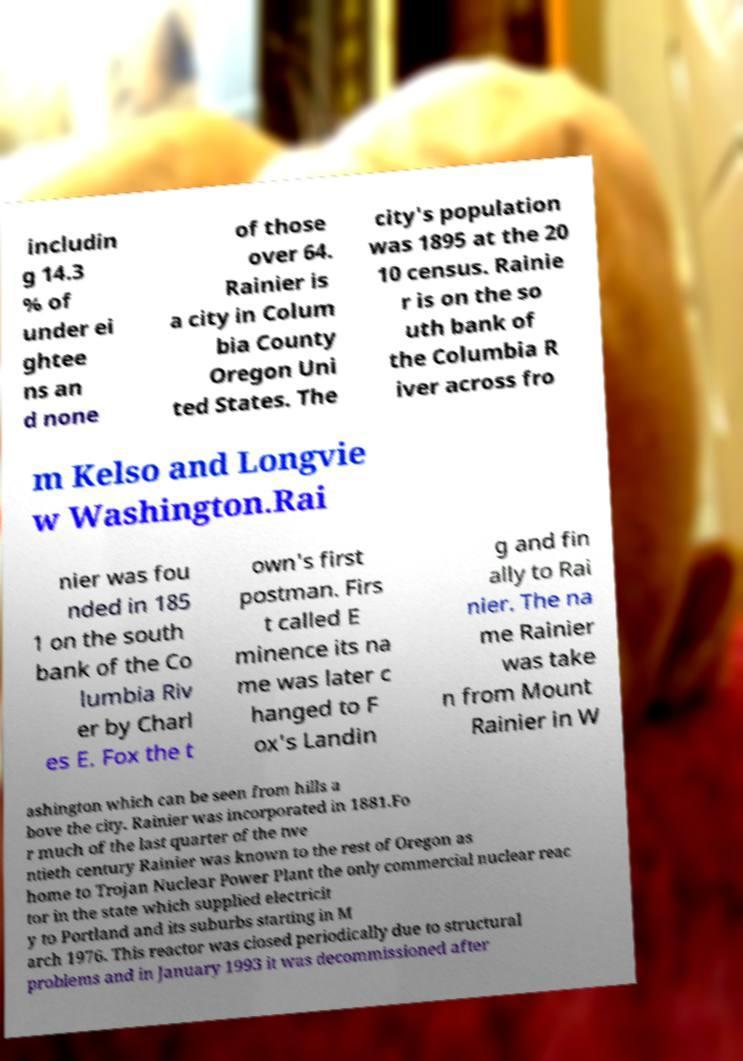Could you extract and type out the text from this image? includin g 14.3 % of under ei ghtee ns an d none of those over 64. Rainier is a city in Colum bia County Oregon Uni ted States. The city's population was 1895 at the 20 10 census. Rainie r is on the so uth bank of the Columbia R iver across fro m Kelso and Longvie w Washington.Rai nier was fou nded in 185 1 on the south bank of the Co lumbia Riv er by Charl es E. Fox the t own's first postman. Firs t called E minence its na me was later c hanged to F ox's Landin g and fin ally to Rai nier. The na me Rainier was take n from Mount Rainier in W ashington which can be seen from hills a bove the city. Rainier was incorporated in 1881.Fo r much of the last quarter of the twe ntieth century Rainier was known to the rest of Oregon as home to Trojan Nuclear Power Plant the only commercial nuclear reac tor in the state which supplied electricit y to Portland and its suburbs starting in M arch 1976. This reactor was closed periodically due to structural problems and in January 1993 it was decommissioned after 